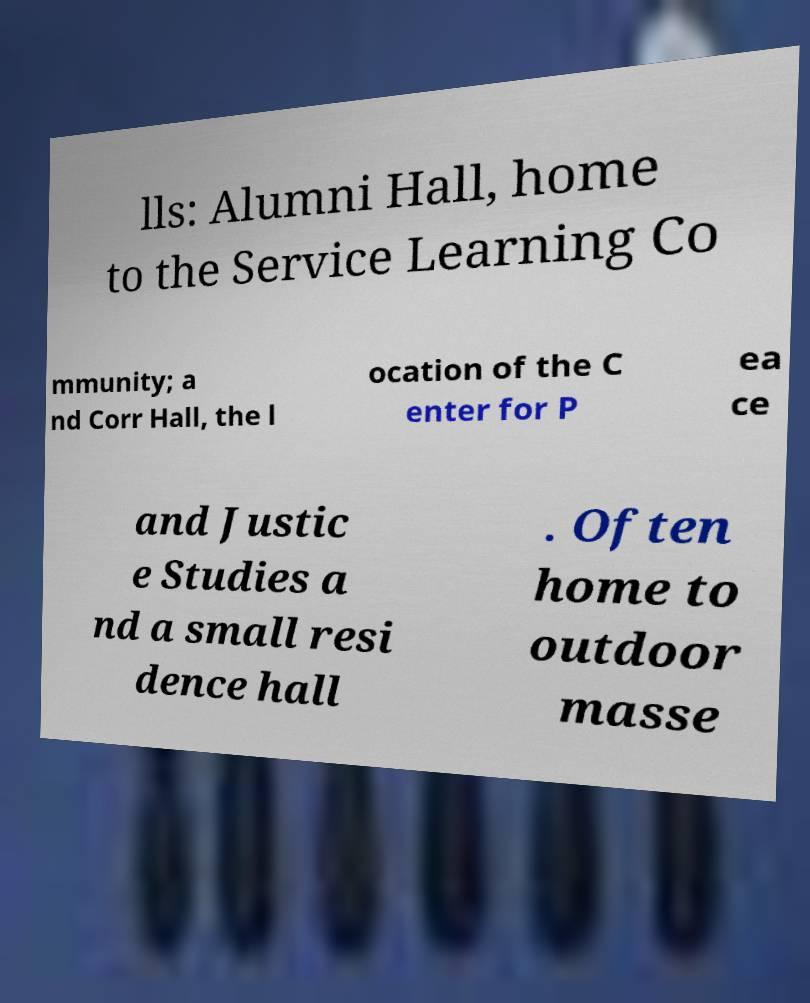Could you assist in decoding the text presented in this image and type it out clearly? lls: Alumni Hall, home to the Service Learning Co mmunity; a nd Corr Hall, the l ocation of the C enter for P ea ce and Justic e Studies a nd a small resi dence hall . Often home to outdoor masse 